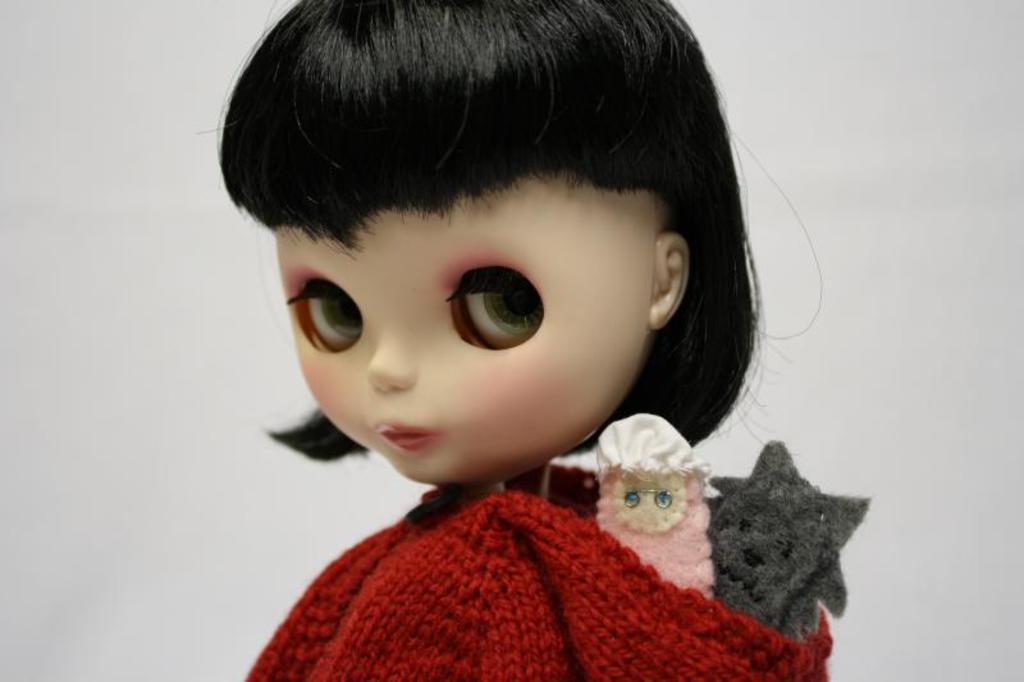What type of toy is present in the image? There is a girl toy in the image. What type of current can be seen flowing through the clam in the wilderness in the image? There is no current, clam, or wilderness present in the image; it only features a girl toy. 